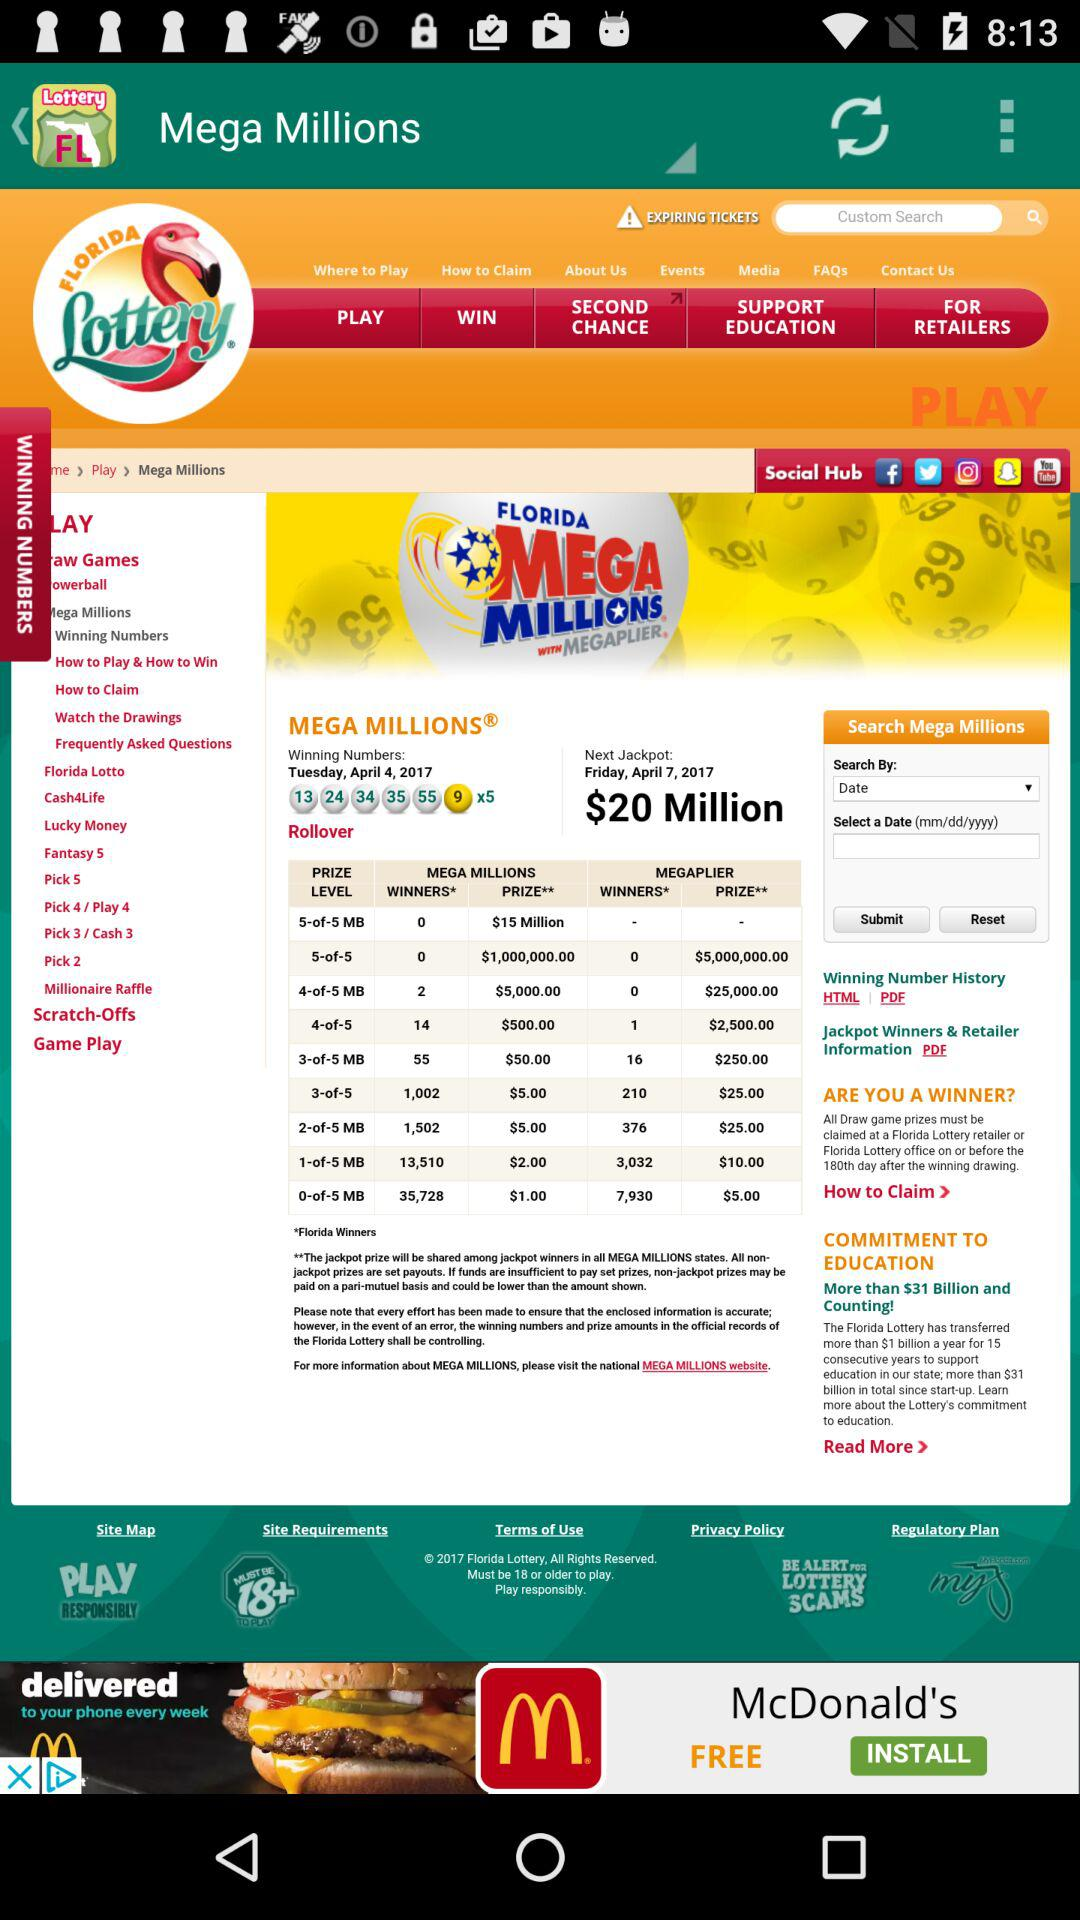Which number is mentioned as the winning number? The winning numbers are 13, 24, 34, 35, 55 and 9. 